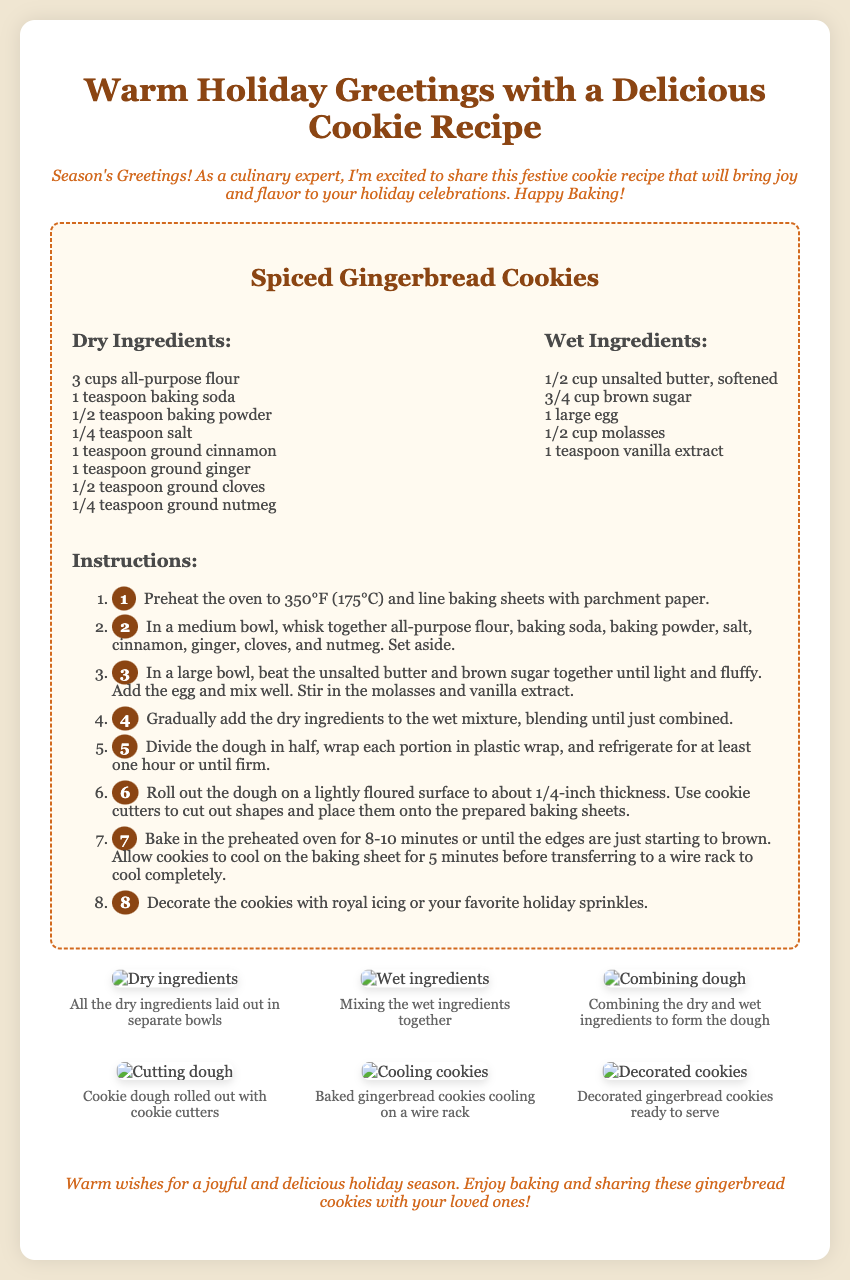What is the title of the recipe? The title of the recipe is mentioned in the header of the recipe section.
Answer: Spiced Gingerbread Cookies How many cups of all-purpose flour are needed? The quantity of all-purpose flour is listed under the dry ingredients section.
Answer: 3 cups What is the baking temperature in Fahrenheit? The baking temperature is stated in the instructions for preheating the oven.
Answer: 350°F What step involves combining the dry ingredients? The specific step where dry ingredients are combined is noted in the instructions.
Answer: Step 2 How long should the cookies bake in total? The total baking time is indicated in the instructions for baking cookies.
Answer: 8-10 minutes What’s the first step in the cookie-making process? The first step is mentioned at the beginning of the instructions.
Answer: Preheat the oven to 350°F What are the illustrations meant to show? The illustrations depict different stages of the cookie-making process as stated in the captions.
Answer: Stages of making cookies What color is the greeting card background? The background color is described in the style section of the document.
Answer: #f0e6d2 What are the closing wishes for the holiday season? The closing statement provides the wishes for the holiday season as a final message.
Answer: Warm wishes for a joyful and delicious holiday season 